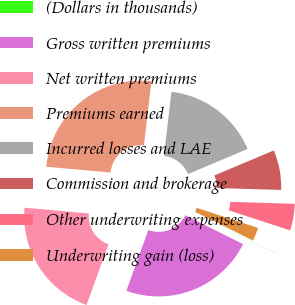Convert chart. <chart><loc_0><loc_0><loc_500><loc_500><pie_chart><fcel>(Dollars in thousands)<fcel>Gross written premiums<fcel>Net written premiums<fcel>Premiums earned<fcel>Incurred losses and LAE<fcel>Commission and brokerage<fcel>Other underwriting expenses<fcel>Underwriting gain (loss)<nl><fcel>0.03%<fcel>23.16%<fcel>20.9%<fcel>25.43%<fcel>16.8%<fcel>6.82%<fcel>4.56%<fcel>2.29%<nl></chart> 